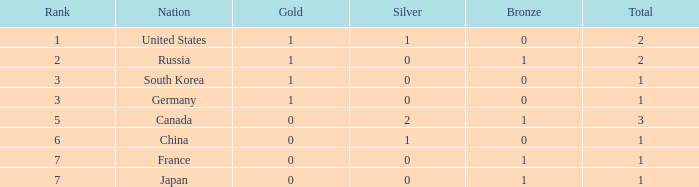Which Rank has a Nation of south korea, and a Silver larger than 0? None. 